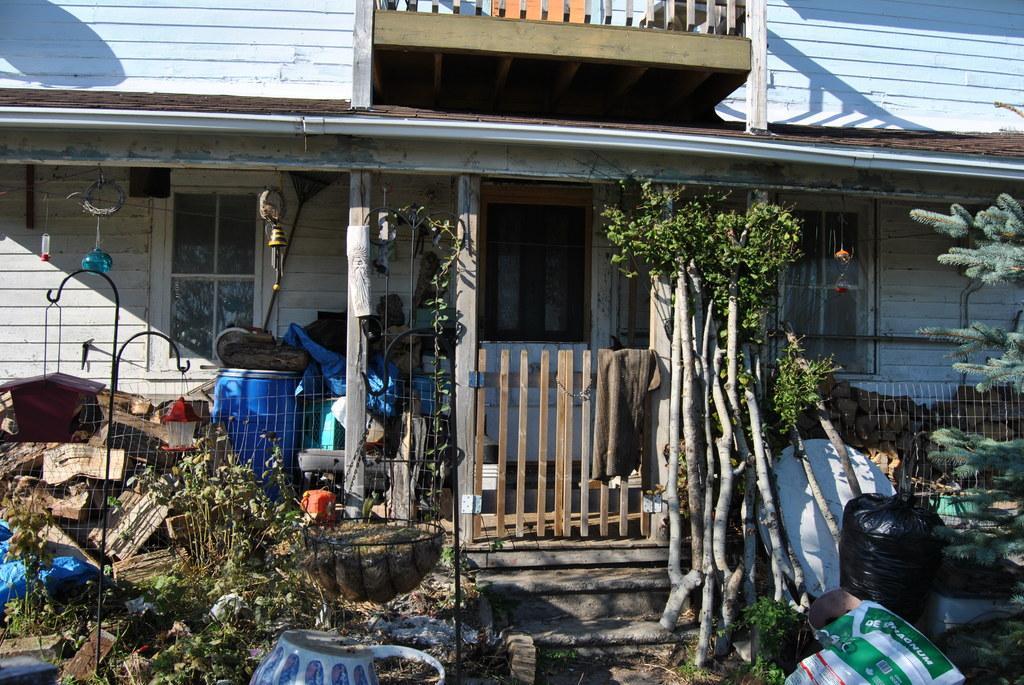Can you describe this image briefly? In the image there is a home in the back with windows on either side with a door in the middle, in the front there is a wooden gate with fence on either side along with sticks,covers and plants. 